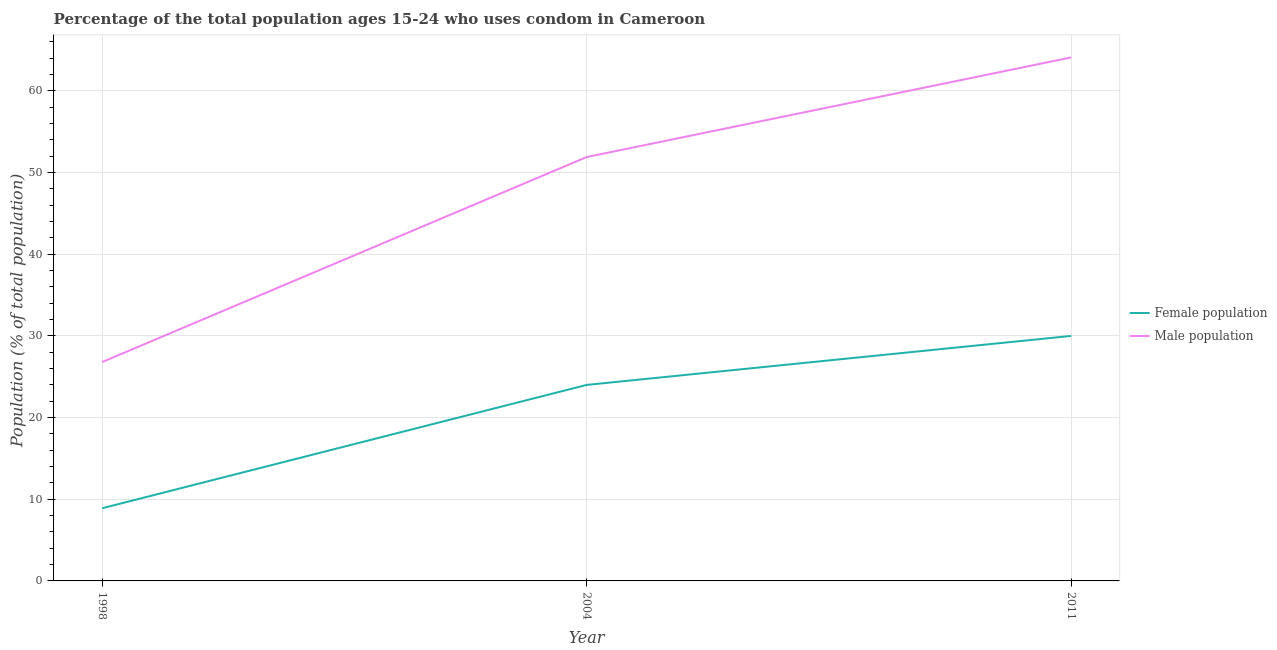Does the line corresponding to male population intersect with the line corresponding to female population?
Offer a very short reply. No. Is the number of lines equal to the number of legend labels?
Your response must be concise. Yes. What is the male population in 2004?
Keep it short and to the point. 51.9. Across all years, what is the maximum male population?
Offer a terse response. 64.1. Across all years, what is the minimum male population?
Offer a terse response. 26.8. In which year was the female population maximum?
Give a very brief answer. 2011. What is the total male population in the graph?
Your response must be concise. 142.8. What is the difference between the female population in 1998 and that in 2011?
Make the answer very short. -21.1. What is the difference between the female population in 2011 and the male population in 1998?
Your answer should be compact. 3.2. What is the average male population per year?
Offer a terse response. 47.6. In the year 2011, what is the difference between the male population and female population?
Provide a succinct answer. 34.1. What is the ratio of the male population in 2004 to that in 2011?
Provide a succinct answer. 0.81. Is the male population in 1998 less than that in 2011?
Offer a terse response. Yes. Is the difference between the female population in 1998 and 2004 greater than the difference between the male population in 1998 and 2004?
Offer a very short reply. Yes. What is the difference between the highest and the second highest female population?
Provide a succinct answer. 6. What is the difference between the highest and the lowest female population?
Offer a terse response. 21.1. In how many years, is the female population greater than the average female population taken over all years?
Provide a succinct answer. 2. Is the sum of the female population in 1998 and 2011 greater than the maximum male population across all years?
Keep it short and to the point. No. Does the female population monotonically increase over the years?
Offer a very short reply. Yes. Is the female population strictly greater than the male population over the years?
Ensure brevity in your answer.  No. Is the female population strictly less than the male population over the years?
Provide a short and direct response. Yes. How many lines are there?
Give a very brief answer. 2. Does the graph contain grids?
Offer a very short reply. Yes. How many legend labels are there?
Make the answer very short. 2. What is the title of the graph?
Your response must be concise. Percentage of the total population ages 15-24 who uses condom in Cameroon. What is the label or title of the Y-axis?
Your response must be concise. Population (% of total population) . What is the Population (% of total population)  in Female population in 1998?
Your response must be concise. 8.9. What is the Population (% of total population)  in Male population in 1998?
Your answer should be compact. 26.8. What is the Population (% of total population)  in Female population in 2004?
Keep it short and to the point. 24. What is the Population (% of total population)  in Male population in 2004?
Your answer should be compact. 51.9. What is the Population (% of total population)  in Male population in 2011?
Your answer should be very brief. 64.1. Across all years, what is the maximum Population (% of total population)  in Female population?
Give a very brief answer. 30. Across all years, what is the maximum Population (% of total population)  of Male population?
Provide a succinct answer. 64.1. Across all years, what is the minimum Population (% of total population)  of Female population?
Give a very brief answer. 8.9. Across all years, what is the minimum Population (% of total population)  of Male population?
Provide a succinct answer. 26.8. What is the total Population (% of total population)  of Female population in the graph?
Your answer should be very brief. 62.9. What is the total Population (% of total population)  in Male population in the graph?
Ensure brevity in your answer.  142.8. What is the difference between the Population (% of total population)  of Female population in 1998 and that in 2004?
Keep it short and to the point. -15.1. What is the difference between the Population (% of total population)  in Male population in 1998 and that in 2004?
Offer a very short reply. -25.1. What is the difference between the Population (% of total population)  in Female population in 1998 and that in 2011?
Give a very brief answer. -21.1. What is the difference between the Population (% of total population)  of Male population in 1998 and that in 2011?
Provide a succinct answer. -37.3. What is the difference between the Population (% of total population)  of Female population in 1998 and the Population (% of total population)  of Male population in 2004?
Keep it short and to the point. -43. What is the difference between the Population (% of total population)  of Female population in 1998 and the Population (% of total population)  of Male population in 2011?
Provide a succinct answer. -55.2. What is the difference between the Population (% of total population)  of Female population in 2004 and the Population (% of total population)  of Male population in 2011?
Provide a succinct answer. -40.1. What is the average Population (% of total population)  of Female population per year?
Make the answer very short. 20.97. What is the average Population (% of total population)  of Male population per year?
Provide a succinct answer. 47.6. In the year 1998, what is the difference between the Population (% of total population)  in Female population and Population (% of total population)  in Male population?
Keep it short and to the point. -17.9. In the year 2004, what is the difference between the Population (% of total population)  in Female population and Population (% of total population)  in Male population?
Keep it short and to the point. -27.9. In the year 2011, what is the difference between the Population (% of total population)  of Female population and Population (% of total population)  of Male population?
Keep it short and to the point. -34.1. What is the ratio of the Population (% of total population)  in Female population in 1998 to that in 2004?
Provide a short and direct response. 0.37. What is the ratio of the Population (% of total population)  in Male population in 1998 to that in 2004?
Keep it short and to the point. 0.52. What is the ratio of the Population (% of total population)  in Female population in 1998 to that in 2011?
Offer a very short reply. 0.3. What is the ratio of the Population (% of total population)  in Male population in 1998 to that in 2011?
Your answer should be compact. 0.42. What is the ratio of the Population (% of total population)  in Male population in 2004 to that in 2011?
Your response must be concise. 0.81. What is the difference between the highest and the lowest Population (% of total population)  of Female population?
Keep it short and to the point. 21.1. What is the difference between the highest and the lowest Population (% of total population)  of Male population?
Your answer should be compact. 37.3. 